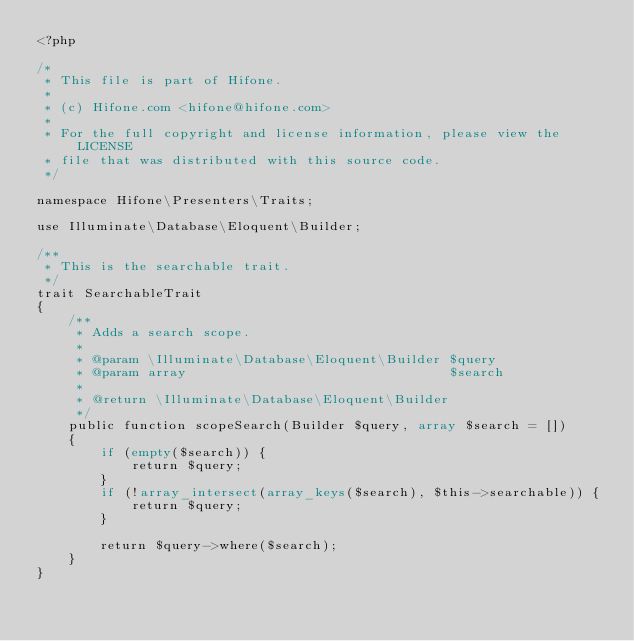Convert code to text. <code><loc_0><loc_0><loc_500><loc_500><_PHP_><?php

/*
 * This file is part of Hifone.
 *
 * (c) Hifone.com <hifone@hifone.com>
 *
 * For the full copyright and license information, please view the LICENSE
 * file that was distributed with this source code.
 */

namespace Hifone\Presenters\Traits;

use Illuminate\Database\Eloquent\Builder;

/**
 * This is the searchable trait.
 */
trait SearchableTrait
{
    /**
     * Adds a search scope.
     *
     * @param \Illuminate\Database\Eloquent\Builder $query
     * @param array                                 $search
     *
     * @return \Illuminate\Database\Eloquent\Builder
     */
    public function scopeSearch(Builder $query, array $search = [])
    {
        if (empty($search)) {
            return $query;
        }
        if (!array_intersect(array_keys($search), $this->searchable)) {
            return $query;
        }

        return $query->where($search);
    }
}
</code> 